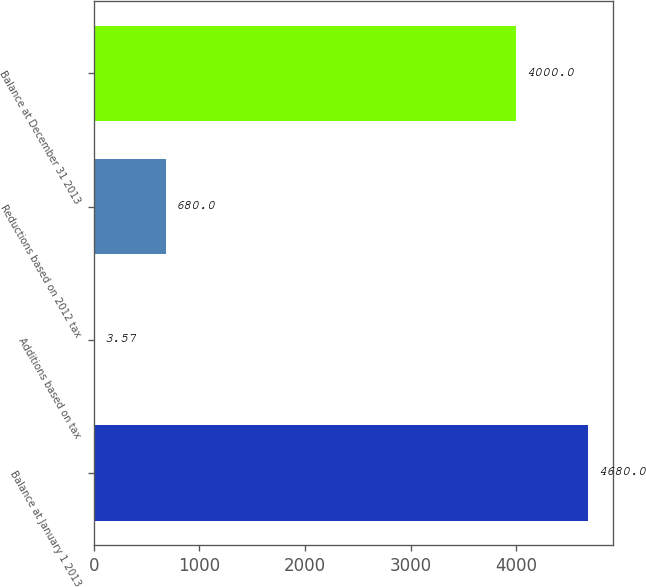<chart> <loc_0><loc_0><loc_500><loc_500><bar_chart><fcel>Balance at January 1 2013<fcel>Additions based on tax<fcel>Reductions based on 2012 tax<fcel>Balance at December 31 2013<nl><fcel>4680<fcel>3.57<fcel>680<fcel>4000<nl></chart> 